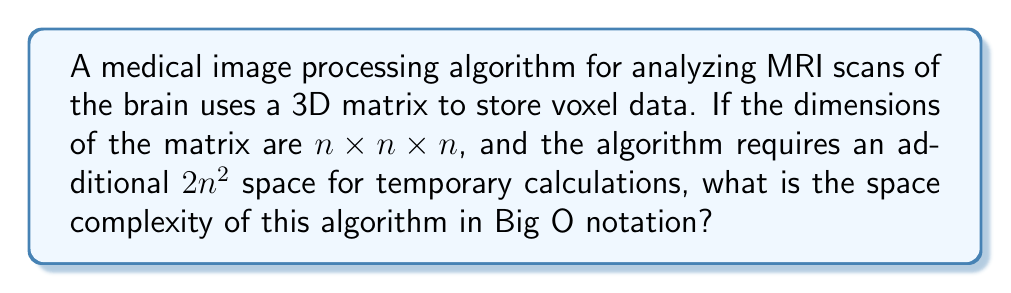Could you help me with this problem? To determine the space complexity, we need to consider all space used by the algorithm:

1. 3D Matrix Storage:
   - The main data structure is a 3D matrix of size $n \times n \times n$.
   - This requires $O(n^3)$ space.

2. Additional Space:
   - The algorithm uses $2n^2$ extra space for calculations.
   - This is $O(n^2)$ space.

3. Combining Space Requirements:
   - Total space = Space for 3D matrix + Additional space
   - $O(n^3) + O(n^2)$

4. Simplifying:
   - When we have multiple terms in Big O notation, we keep the term with the highest growth rate.
   - $n^3$ grows faster than $n^2$ as $n$ increases.
   - Therefore, $O(n^3)$ dominates $O(n^2)$.

5. Final Space Complexity:
   - The overall space complexity is $O(n^3)$.

This analysis shows that the space requirement grows cubically with the input size, which is typical for 3D image processing algorithms. As a medical student, understanding this helps in assessing the scalability of medical imaging software for different sizes of MRI scans.
Answer: $O(n^3)$ 